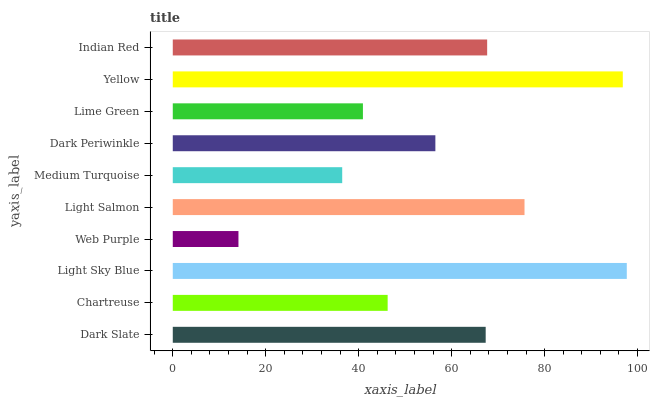Is Web Purple the minimum?
Answer yes or no. Yes. Is Light Sky Blue the maximum?
Answer yes or no. Yes. Is Chartreuse the minimum?
Answer yes or no. No. Is Chartreuse the maximum?
Answer yes or no. No. Is Dark Slate greater than Chartreuse?
Answer yes or no. Yes. Is Chartreuse less than Dark Slate?
Answer yes or no. Yes. Is Chartreuse greater than Dark Slate?
Answer yes or no. No. Is Dark Slate less than Chartreuse?
Answer yes or no. No. Is Dark Slate the high median?
Answer yes or no. Yes. Is Dark Periwinkle the low median?
Answer yes or no. Yes. Is Light Sky Blue the high median?
Answer yes or no. No. Is Web Purple the low median?
Answer yes or no. No. 